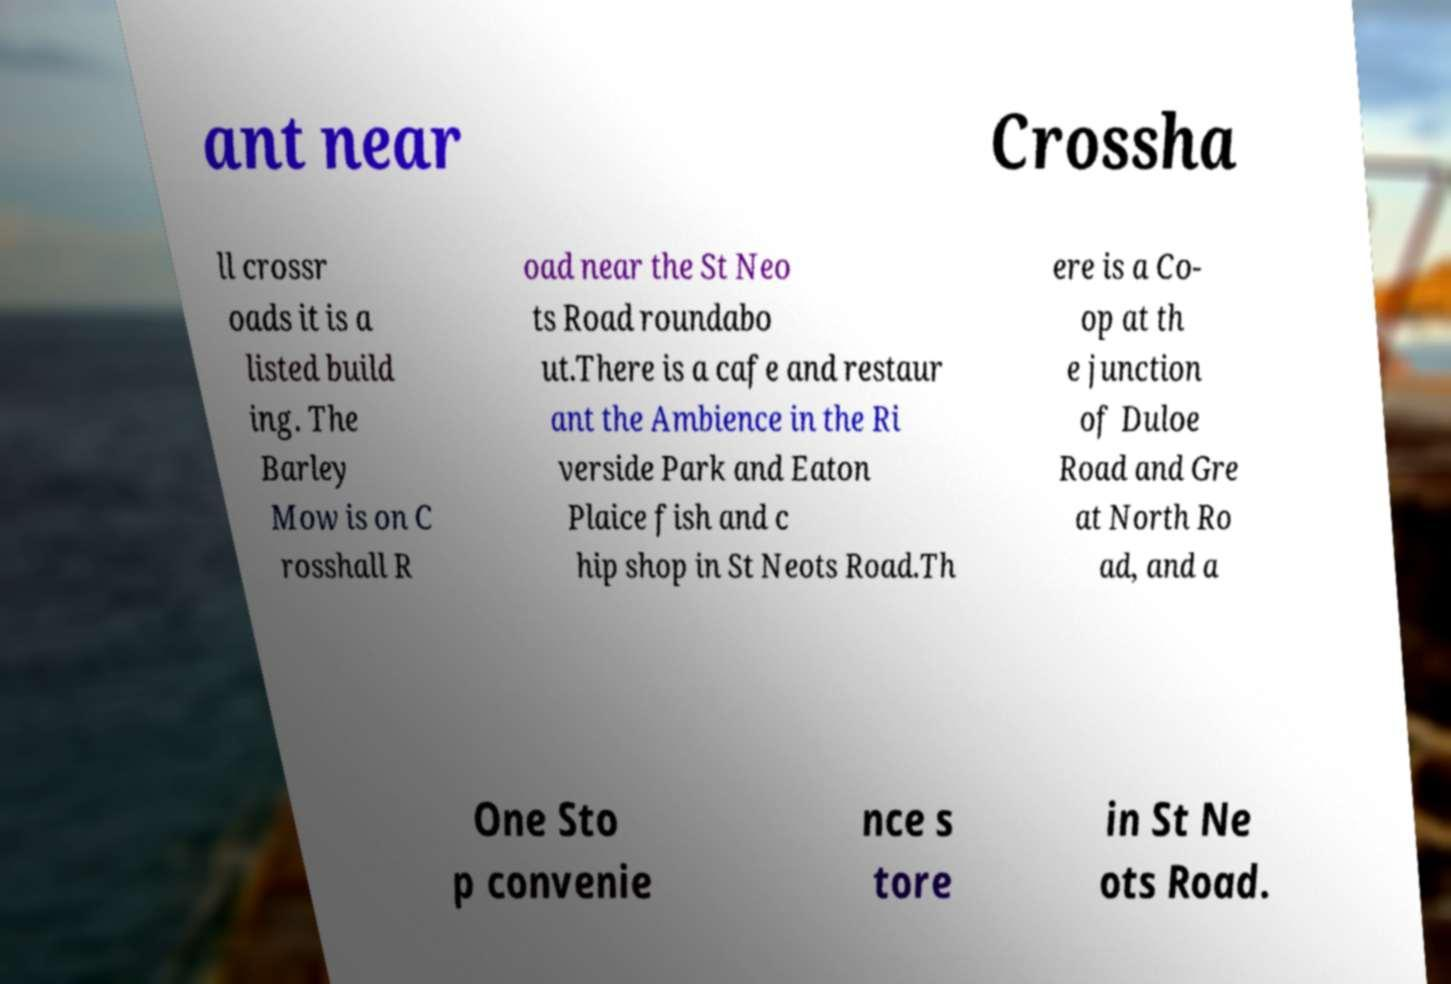Can you read and provide the text displayed in the image?This photo seems to have some interesting text. Can you extract and type it out for me? ant near Crossha ll crossr oads it is a listed build ing. The Barley Mow is on C rosshall R oad near the St Neo ts Road roundabo ut.There is a cafe and restaur ant the Ambience in the Ri verside Park and Eaton Plaice fish and c hip shop in St Neots Road.Th ere is a Co- op at th e junction of Duloe Road and Gre at North Ro ad, and a One Sto p convenie nce s tore in St Ne ots Road. 